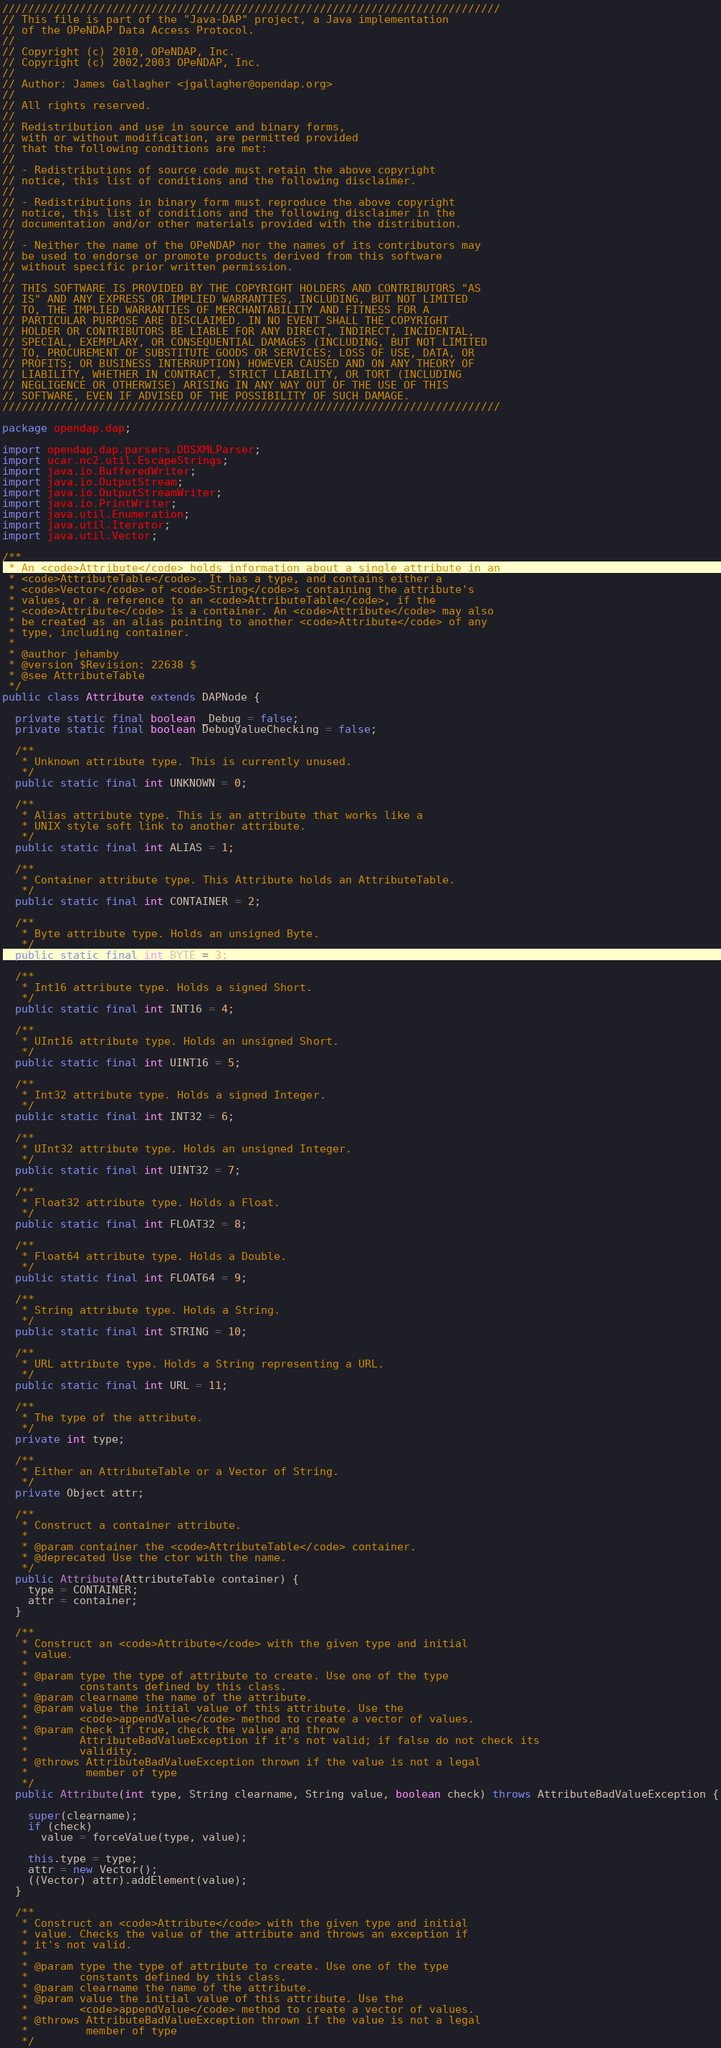<code> <loc_0><loc_0><loc_500><loc_500><_Java_>/////////////////////////////////////////////////////////////////////////////
// This file is part of the "Java-DAP" project, a Java implementation
// of the OPeNDAP Data Access Protocol.
//
// Copyright (c) 2010, OPeNDAP, Inc.
// Copyright (c) 2002,2003 OPeNDAP, Inc.
//
// Author: James Gallagher <jgallagher@opendap.org>
//
// All rights reserved.
//
// Redistribution and use in source and binary forms,
// with or without modification, are permitted provided
// that the following conditions are met:
//
// - Redistributions of source code must retain the above copyright
// notice, this list of conditions and the following disclaimer.
//
// - Redistributions in binary form must reproduce the above copyright
// notice, this list of conditions and the following disclaimer in the
// documentation and/or other materials provided with the distribution.
//
// - Neither the name of the OPeNDAP nor the names of its contributors may
// be used to endorse or promote products derived from this software
// without specific prior written permission.
//
// THIS SOFTWARE IS PROVIDED BY THE COPYRIGHT HOLDERS AND CONTRIBUTORS "AS
// IS" AND ANY EXPRESS OR IMPLIED WARRANTIES, INCLUDING, BUT NOT LIMITED
// TO, THE IMPLIED WARRANTIES OF MERCHANTABILITY AND FITNESS FOR A
// PARTICULAR PURPOSE ARE DISCLAIMED. IN NO EVENT SHALL THE COPYRIGHT
// HOLDER OR CONTRIBUTORS BE LIABLE FOR ANY DIRECT, INDIRECT, INCIDENTAL,
// SPECIAL, EXEMPLARY, OR CONSEQUENTIAL DAMAGES (INCLUDING, BUT NOT LIMITED
// TO, PROCUREMENT OF SUBSTITUTE GOODS OR SERVICES; LOSS OF USE, DATA, OR
// PROFITS; OR BUSINESS INTERRUPTION) HOWEVER CAUSED AND ON ANY THEORY OF
// LIABILITY, WHETHER IN CONTRACT, STRICT LIABILITY, OR TORT (INCLUDING
// NEGLIGENCE OR OTHERWISE) ARISING IN ANY WAY OUT OF THE USE OF THIS
// SOFTWARE, EVEN IF ADVISED OF THE POSSIBILITY OF SUCH DAMAGE.
/////////////////////////////////////////////////////////////////////////////

package opendap.dap;

import opendap.dap.parsers.DDSXMLParser;
import ucar.nc2.util.EscapeStrings;
import java.io.BufferedWriter;
import java.io.OutputStream;
import java.io.OutputStreamWriter;
import java.io.PrintWriter;
import java.util.Enumeration;
import java.util.Iterator;
import java.util.Vector;

/**
 * An <code>Attribute</code> holds information about a single attribute in an
 * <code>AttributeTable</code>. It has a type, and contains either a
 * <code>Vector</code> of <code>String</code>s containing the attribute's
 * values, or a reference to an <code>AttributeTable</code>, if the
 * <code>Attribute</code> is a container. An <code>Attribute</code> may also
 * be created as an alias pointing to another <code>Attribute</code> of any
 * type, including container.
 *
 * @author jehamby
 * @version $Revision: 22638 $
 * @see AttributeTable
 */
public class Attribute extends DAPNode {

  private static final boolean _Debug = false;
  private static final boolean DebugValueChecking = false;

  /**
   * Unknown attribute type. This is currently unused.
   */
  public static final int UNKNOWN = 0;

  /**
   * Alias attribute type. This is an attribute that works like a
   * UNIX style soft link to another attribute.
   */
  public static final int ALIAS = 1;

  /**
   * Container attribute type. This Attribute holds an AttributeTable.
   */
  public static final int CONTAINER = 2;

  /**
   * Byte attribute type. Holds an unsigned Byte.
   */
  public static final int BYTE = 3;

  /**
   * Int16 attribute type. Holds a signed Short.
   */
  public static final int INT16 = 4;

  /**
   * UInt16 attribute type. Holds an unsigned Short.
   */
  public static final int UINT16 = 5;

  /**
   * Int32 attribute type. Holds a signed Integer.
   */
  public static final int INT32 = 6;

  /**
   * UInt32 attribute type. Holds an unsigned Integer.
   */
  public static final int UINT32 = 7;

  /**
   * Float32 attribute type. Holds a Float.
   */
  public static final int FLOAT32 = 8;

  /**
   * Float64 attribute type. Holds a Double.
   */
  public static final int FLOAT64 = 9;

  /**
   * String attribute type. Holds a String.
   */
  public static final int STRING = 10;

  /**
   * URL attribute type. Holds a String representing a URL.
   */
  public static final int URL = 11;

  /**
   * The type of the attribute.
   */
  private int type;

  /**
   * Either an AttributeTable or a Vector of String.
   */
  private Object attr;

  /**
   * Construct a container attribute.
   *
   * @param container the <code>AttributeTable</code> container.
   * @deprecated Use the ctor with the name.
   */
  public Attribute(AttributeTable container) {
    type = CONTAINER;
    attr = container;
  }

  /**
   * Construct an <code>Attribute</code> with the given type and initial
   * value.
   *
   * @param type the type of attribute to create. Use one of the type
   *        constants defined by this class.
   * @param clearname the name of the attribute.
   * @param value the initial value of this attribute. Use the
   *        <code>appendValue</code> method to create a vector of values.
   * @param check if true, check the value and throw
   *        AttributeBadValueException if it's not valid; if false do not check its
   *        validity.
   * @throws AttributeBadValueException thrown if the value is not a legal
   *         member of type
   */
  public Attribute(int type, String clearname, String value, boolean check) throws AttributeBadValueException {

    super(clearname);
    if (check)
      value = forceValue(type, value);

    this.type = type;
    attr = new Vector();
    ((Vector) attr).addElement(value);
  }

  /**
   * Construct an <code>Attribute</code> with the given type and initial
   * value. Checks the value of the attribute and throws an exception if
   * it's not valid.
   *
   * @param type the type of attribute to create. Use one of the type
   *        constants defined by this class.
   * @param clearname the name of the attribute.
   * @param value the initial value of this attribute. Use the
   *        <code>appendValue</code> method to create a vector of values.
   * @throws AttributeBadValueException thrown if the value is not a legal
   *         member of type
   */</code> 